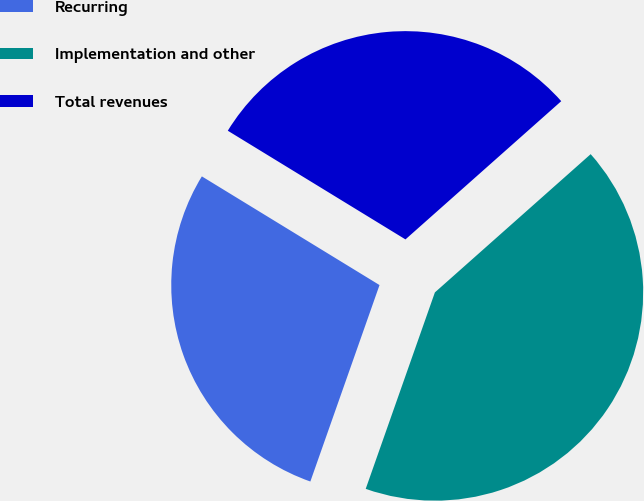Convert chart. <chart><loc_0><loc_0><loc_500><loc_500><pie_chart><fcel>Recurring<fcel>Implementation and other<fcel>Total revenues<nl><fcel>28.35%<fcel>41.94%<fcel>29.71%<nl></chart> 